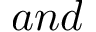<formula> <loc_0><loc_0><loc_500><loc_500>a n d</formula> 